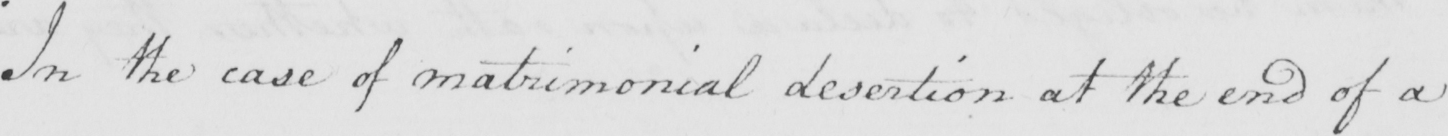Can you tell me what this handwritten text says? In the case of matrimonial desertion at the end of a 